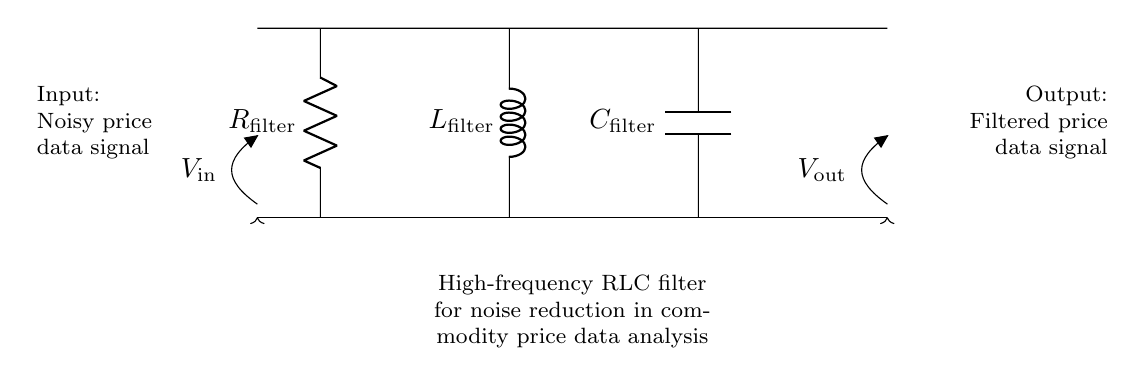What type of filter is shown in the circuit? The circuit is a high-frequency RLC filter, indicated by the configuration of a resistor, inductor, and capacitor arranged to attenuate high-frequency noise in signals.
Answer: high-frequency RLC filter What is the function of the resistor in this RLC filter? The resistor serves to limit the current and dissipate power, which contributes to defining the filter's damping behavior and helps manage noise reduction by adjusting the overall circuit impedance.
Answer: limits current What components are involved in the noise reduction circuit? The circuit consists of three components: a resistor, an inductor, and a capacitor, which together create a filtering effect to remove unwanted high-frequency noise from the input signal.
Answer: resistor, inductor, capacitor What is the input signal represented in the circuit? The input signal, marked as V_in, is the noisy price data signal that is fed into the filter to be processed and cleaned from high-frequency noise.
Answer: noisy price data signal What is the output of this RLC filter? The output signal, labeled as V_out, represents the filtered price data signal, which should have reduced high-frequency noise and provide a cleaner representation of the price movements.
Answer: filtered price data signal How does the arrangement of components affect filtering? The arrangement of the resistor, inductor, and capacitor in parallel creates a second-order filter, which is effective at attenuating high-frequency signals while allowing lower frequencies to pass, thus enhancing the overall noise reduction capability.
Answer: second-order filter What does the letter L represent in the diagram? The letter L represents the inductor component within the RLC filter, which stores energy in a magnetic field and is crucial for the filter's response to frequency changes.
Answer: inductor 